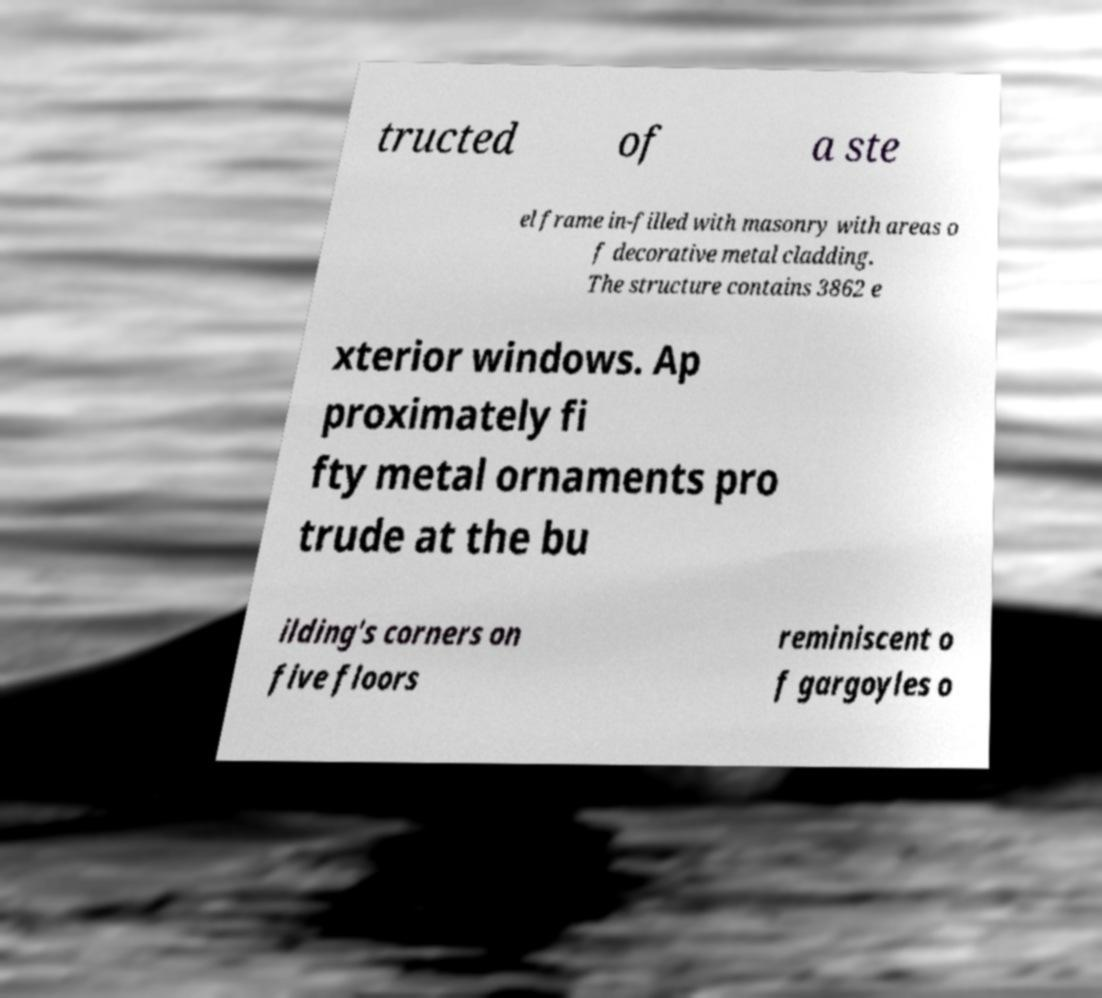Please read and relay the text visible in this image. What does it say? tructed of a ste el frame in-filled with masonry with areas o f decorative metal cladding. The structure contains 3862 e xterior windows. Ap proximately fi fty metal ornaments pro trude at the bu ilding's corners on five floors reminiscent o f gargoyles o 